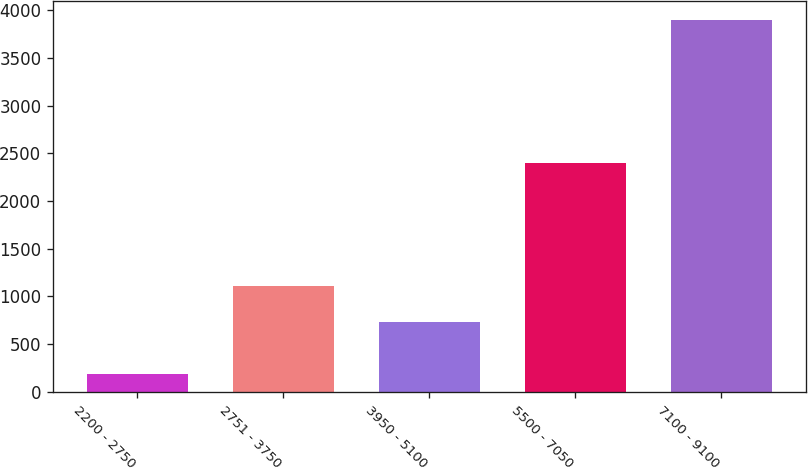Convert chart to OTSL. <chart><loc_0><loc_0><loc_500><loc_500><bar_chart><fcel>2200 - 2750<fcel>2751 - 3750<fcel>3950 - 5100<fcel>5500 - 7050<fcel>7100 - 9100<nl><fcel>187<fcel>1105.3<fcel>734<fcel>2403<fcel>3900<nl></chart> 